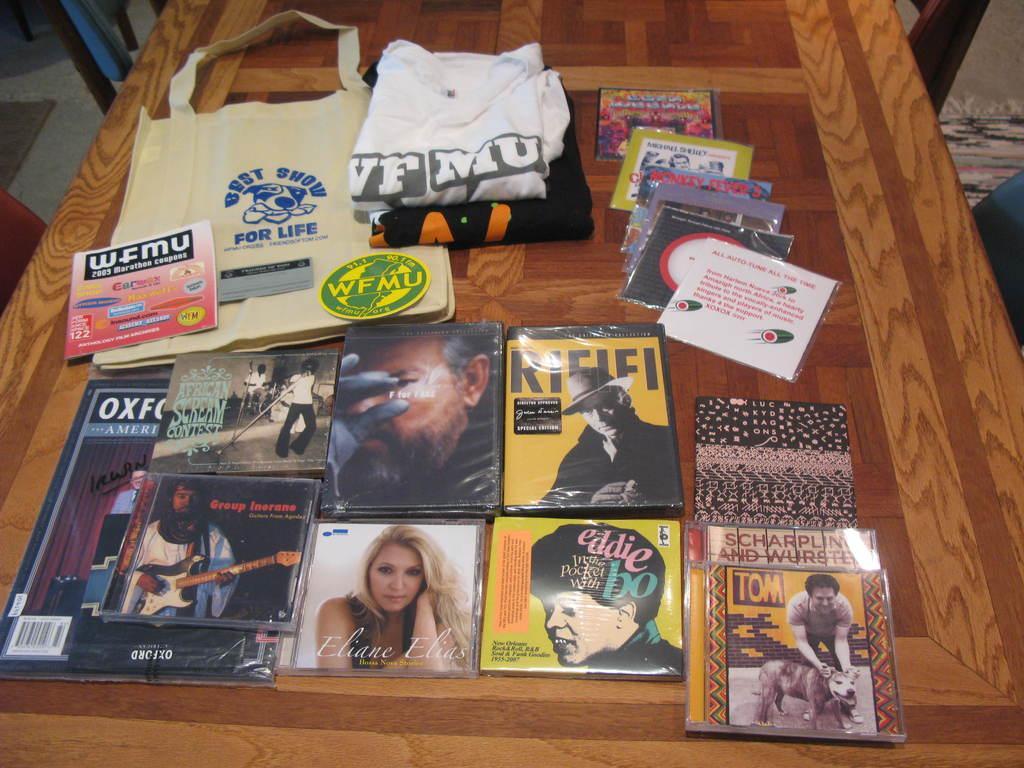Could you give a brief overview of what you see in this image? In this picture I can see many CD packs, t-shirts, bag, book and other objects. On the right I can see the chair near to the wall. On the left there is a carpet on the floor. 